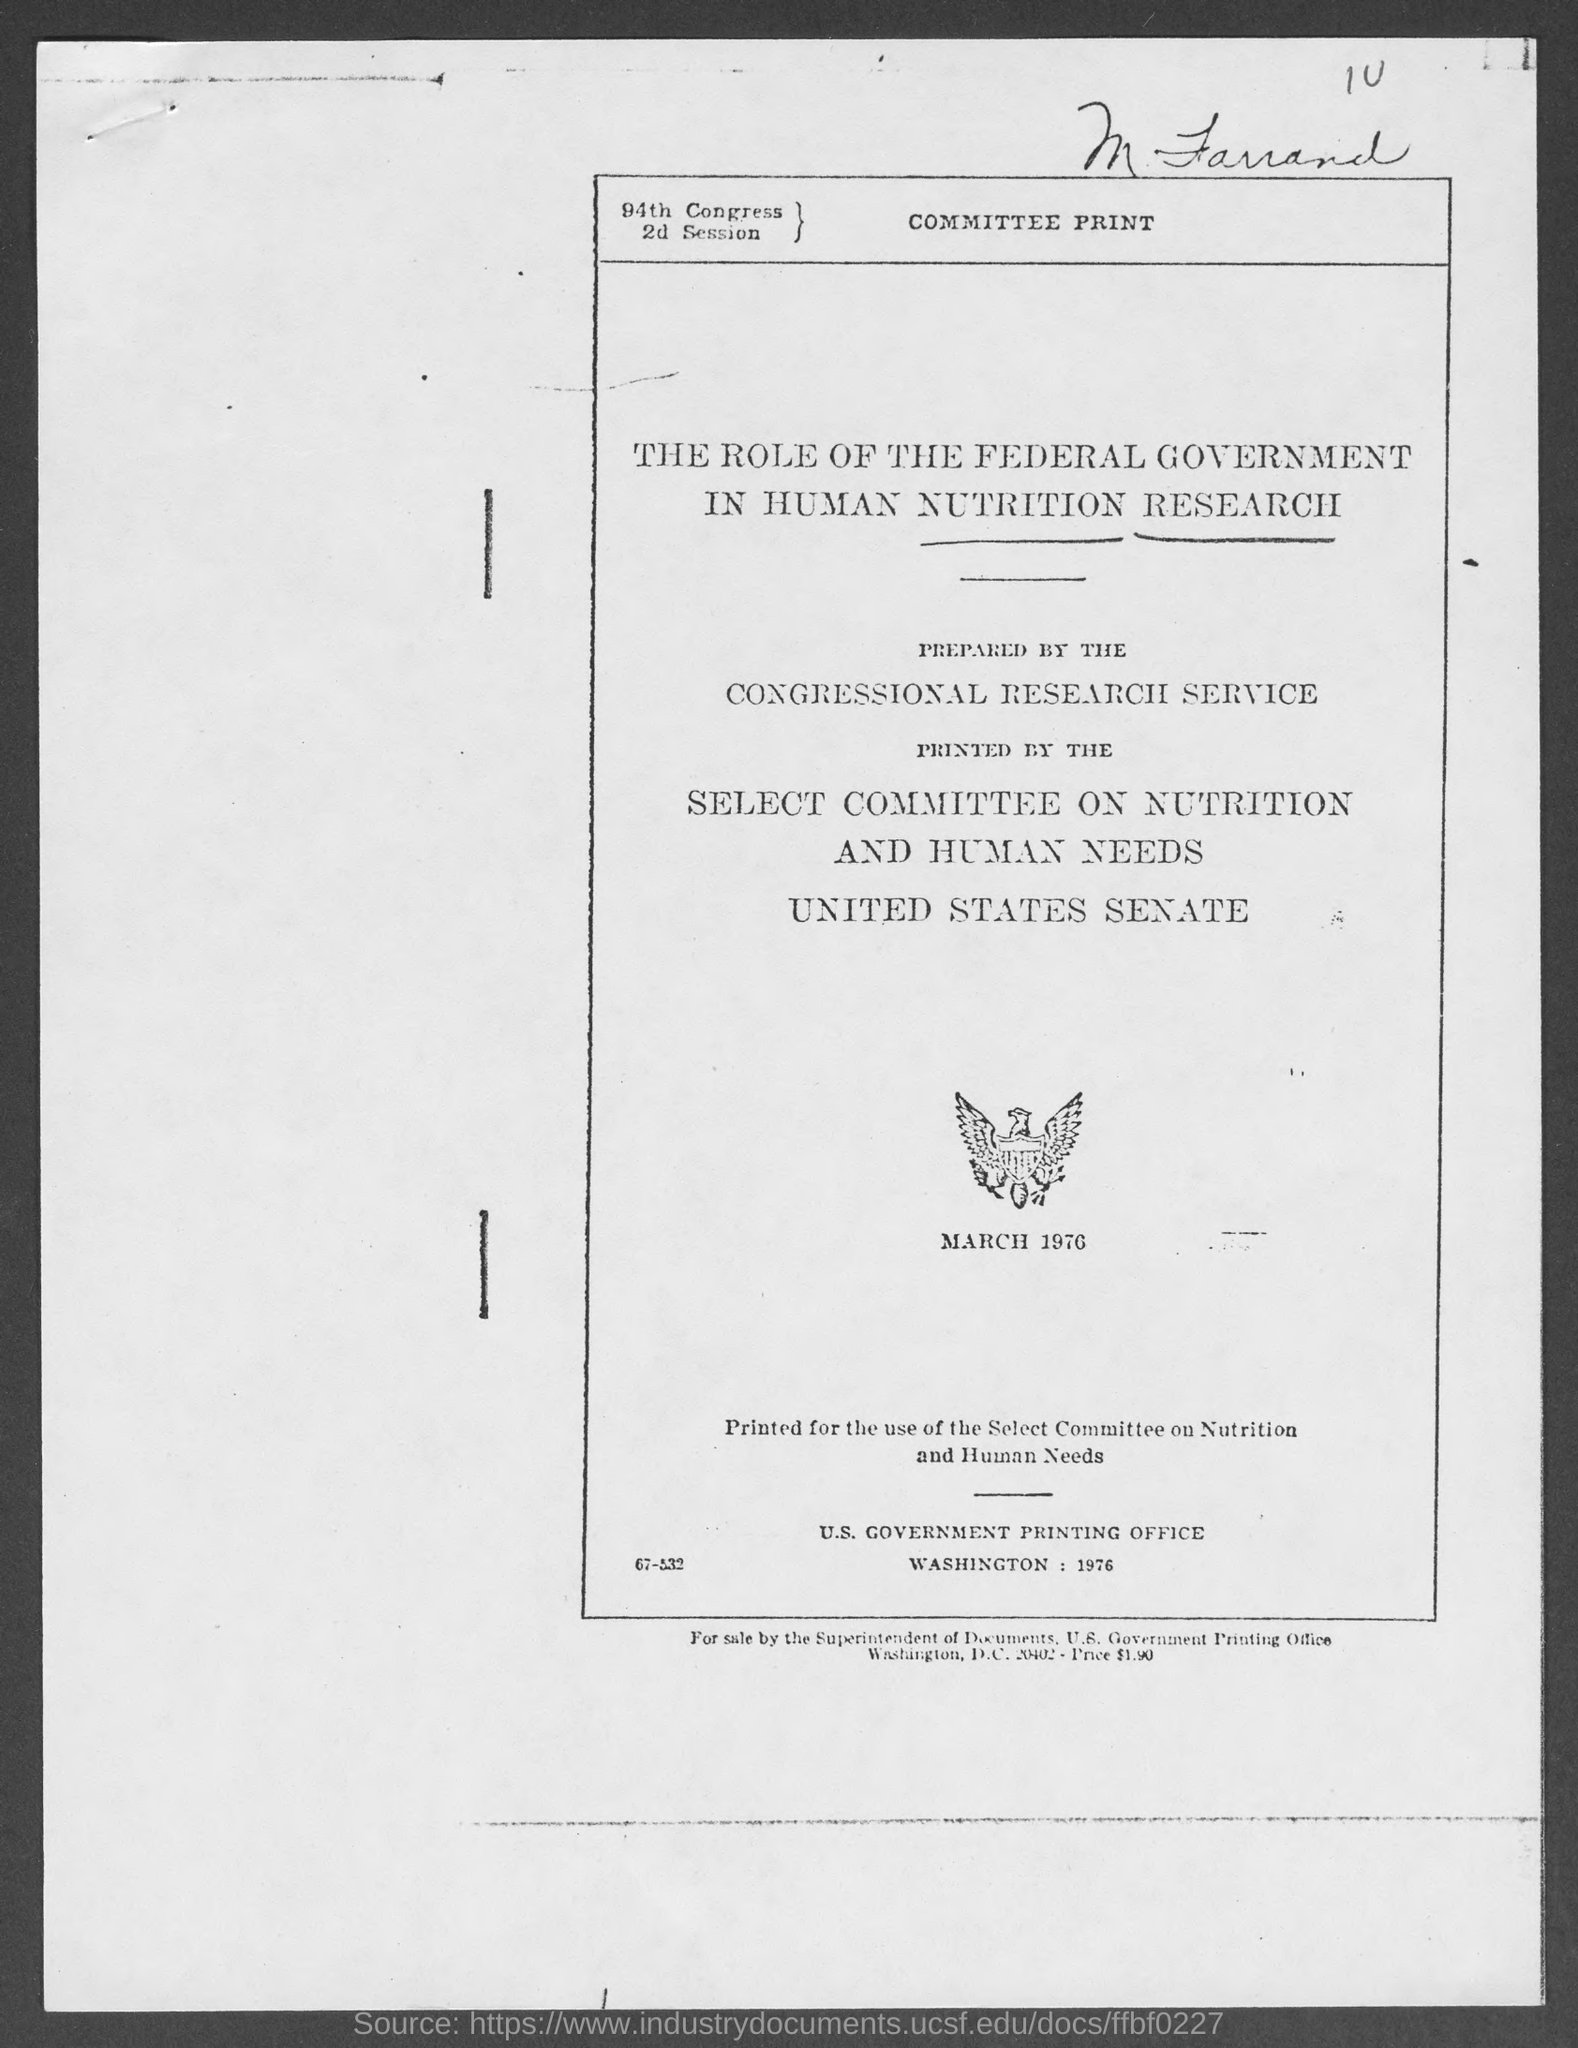What is the price at bottom of the page ?
Give a very brief answer. $1.90. 